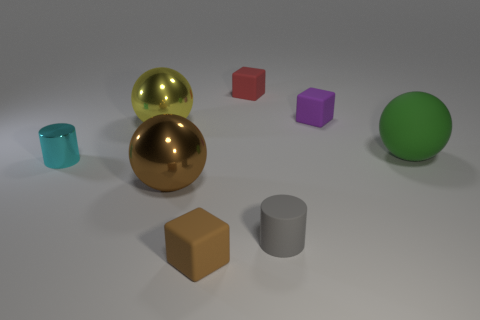Add 1 tiny matte cubes. How many objects exist? 9 Subtract all cubes. How many objects are left? 5 Subtract all big brown metal spheres. Subtract all large yellow balls. How many objects are left? 6 Add 8 tiny purple rubber things. How many tiny purple rubber things are left? 9 Add 3 small gray cylinders. How many small gray cylinders exist? 4 Subtract 0 blue blocks. How many objects are left? 8 